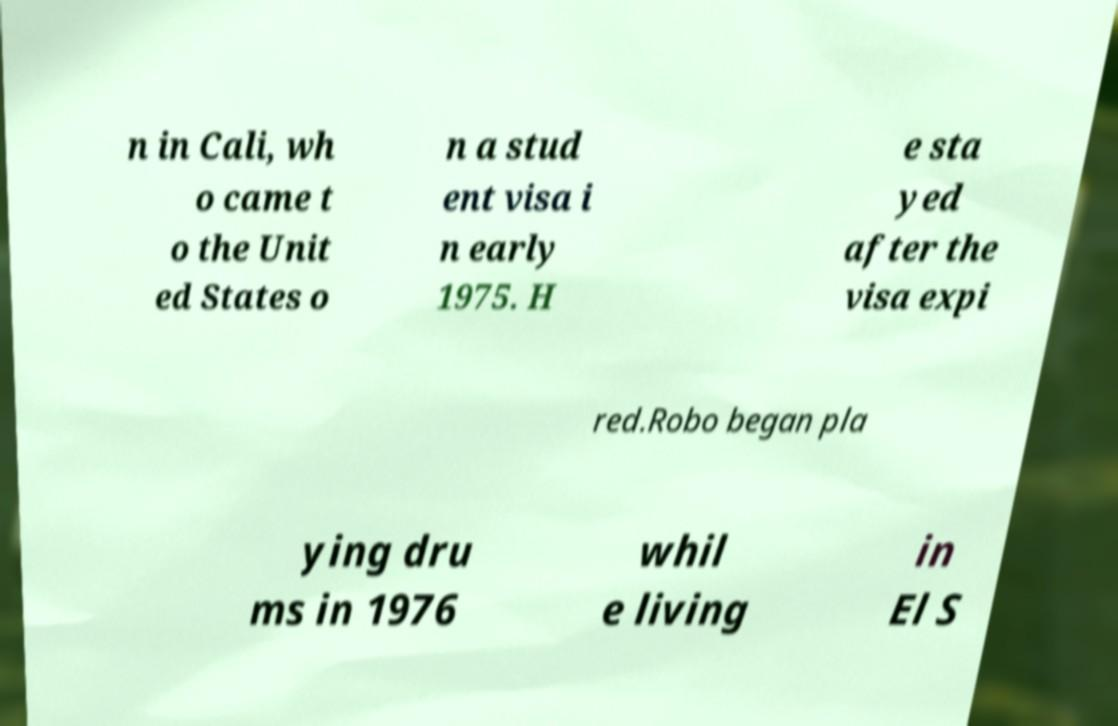Please identify and transcribe the text found in this image. n in Cali, wh o came t o the Unit ed States o n a stud ent visa i n early 1975. H e sta yed after the visa expi red.Robo began pla ying dru ms in 1976 whil e living in El S 